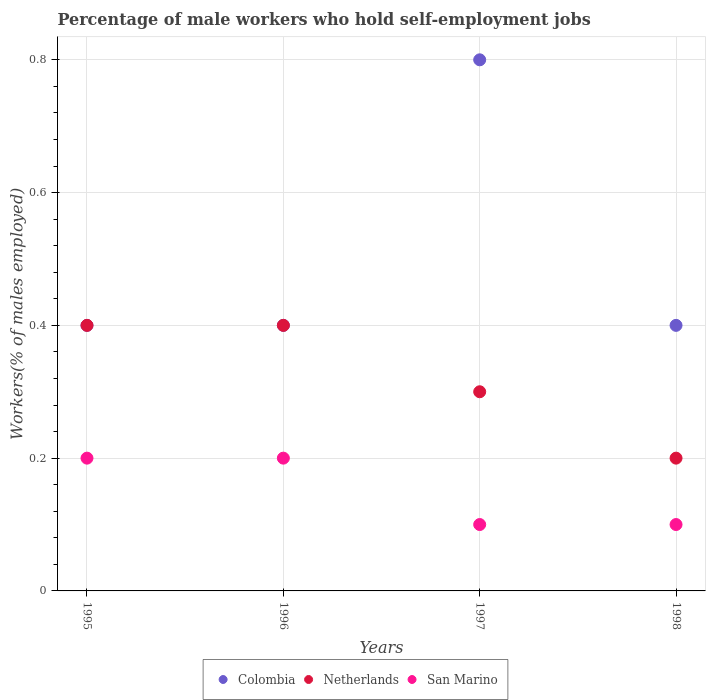How many different coloured dotlines are there?
Your answer should be very brief. 3. What is the percentage of self-employed male workers in San Marino in 1998?
Provide a succinct answer. 0.1. Across all years, what is the maximum percentage of self-employed male workers in San Marino?
Offer a very short reply. 0.2. Across all years, what is the minimum percentage of self-employed male workers in San Marino?
Make the answer very short. 0.1. In which year was the percentage of self-employed male workers in Netherlands maximum?
Ensure brevity in your answer.  1995. What is the total percentage of self-employed male workers in Colombia in the graph?
Offer a terse response. 2. What is the difference between the percentage of self-employed male workers in Netherlands in 1997 and the percentage of self-employed male workers in Colombia in 1996?
Offer a very short reply. -0.1. What is the average percentage of self-employed male workers in Colombia per year?
Ensure brevity in your answer.  0.5. In the year 1995, what is the difference between the percentage of self-employed male workers in San Marino and percentage of self-employed male workers in Netherlands?
Give a very brief answer. -0.2. In how many years, is the percentage of self-employed male workers in Colombia greater than 0.68 %?
Keep it short and to the point. 1. Is the percentage of self-employed male workers in Netherlands in 1997 less than that in 1998?
Offer a terse response. No. Is the difference between the percentage of self-employed male workers in San Marino in 1995 and 1996 greater than the difference between the percentage of self-employed male workers in Netherlands in 1995 and 1996?
Make the answer very short. No. What is the difference between the highest and the second highest percentage of self-employed male workers in Colombia?
Offer a very short reply. 0.4. What is the difference between the highest and the lowest percentage of self-employed male workers in San Marino?
Ensure brevity in your answer.  0.1. In how many years, is the percentage of self-employed male workers in Netherlands greater than the average percentage of self-employed male workers in Netherlands taken over all years?
Your answer should be compact. 2. Is the sum of the percentage of self-employed male workers in San Marino in 1995 and 1998 greater than the maximum percentage of self-employed male workers in Colombia across all years?
Give a very brief answer. No. Is the percentage of self-employed male workers in Netherlands strictly greater than the percentage of self-employed male workers in Colombia over the years?
Offer a terse response. No. Is the percentage of self-employed male workers in Netherlands strictly less than the percentage of self-employed male workers in San Marino over the years?
Make the answer very short. No. How many dotlines are there?
Keep it short and to the point. 3. What is the difference between two consecutive major ticks on the Y-axis?
Ensure brevity in your answer.  0.2. Are the values on the major ticks of Y-axis written in scientific E-notation?
Offer a very short reply. No. Does the graph contain any zero values?
Your answer should be compact. No. Does the graph contain grids?
Offer a very short reply. Yes. Where does the legend appear in the graph?
Your response must be concise. Bottom center. How many legend labels are there?
Your response must be concise. 3. What is the title of the graph?
Offer a terse response. Percentage of male workers who hold self-employment jobs. Does "Low income" appear as one of the legend labels in the graph?
Provide a succinct answer. No. What is the label or title of the X-axis?
Offer a very short reply. Years. What is the label or title of the Y-axis?
Your answer should be compact. Workers(% of males employed). What is the Workers(% of males employed) in Colombia in 1995?
Ensure brevity in your answer.  0.4. What is the Workers(% of males employed) of Netherlands in 1995?
Ensure brevity in your answer.  0.4. What is the Workers(% of males employed) in San Marino in 1995?
Provide a short and direct response. 0.2. What is the Workers(% of males employed) in Colombia in 1996?
Offer a very short reply. 0.4. What is the Workers(% of males employed) in Netherlands in 1996?
Offer a very short reply. 0.4. What is the Workers(% of males employed) in San Marino in 1996?
Give a very brief answer. 0.2. What is the Workers(% of males employed) of Colombia in 1997?
Your response must be concise. 0.8. What is the Workers(% of males employed) of Netherlands in 1997?
Your response must be concise. 0.3. What is the Workers(% of males employed) in San Marino in 1997?
Keep it short and to the point. 0.1. What is the Workers(% of males employed) in Colombia in 1998?
Your answer should be compact. 0.4. What is the Workers(% of males employed) in Netherlands in 1998?
Offer a terse response. 0.2. What is the Workers(% of males employed) of San Marino in 1998?
Your answer should be very brief. 0.1. Across all years, what is the maximum Workers(% of males employed) of Colombia?
Your answer should be compact. 0.8. Across all years, what is the maximum Workers(% of males employed) of Netherlands?
Offer a very short reply. 0.4. Across all years, what is the maximum Workers(% of males employed) in San Marino?
Your response must be concise. 0.2. Across all years, what is the minimum Workers(% of males employed) of Colombia?
Ensure brevity in your answer.  0.4. Across all years, what is the minimum Workers(% of males employed) of Netherlands?
Provide a short and direct response. 0.2. Across all years, what is the minimum Workers(% of males employed) of San Marino?
Your answer should be very brief. 0.1. What is the total Workers(% of males employed) in San Marino in the graph?
Provide a succinct answer. 0.6. What is the difference between the Workers(% of males employed) of Colombia in 1995 and that in 1996?
Your answer should be very brief. 0. What is the difference between the Workers(% of males employed) of Colombia in 1995 and that in 1998?
Keep it short and to the point. 0. What is the difference between the Workers(% of males employed) in Netherlands in 1996 and that in 1997?
Keep it short and to the point. 0.1. What is the difference between the Workers(% of males employed) of Colombia in 1996 and that in 1998?
Offer a terse response. 0. What is the difference between the Workers(% of males employed) in Netherlands in 1996 and that in 1998?
Provide a succinct answer. 0.2. What is the difference between the Workers(% of males employed) in Netherlands in 1997 and that in 1998?
Make the answer very short. 0.1. What is the difference between the Workers(% of males employed) in San Marino in 1997 and that in 1998?
Your answer should be very brief. 0. What is the difference between the Workers(% of males employed) of Colombia in 1995 and the Workers(% of males employed) of San Marino in 1996?
Your answer should be very brief. 0.2. What is the difference between the Workers(% of males employed) in Colombia in 1995 and the Workers(% of males employed) in San Marino in 1997?
Ensure brevity in your answer.  0.3. What is the difference between the Workers(% of males employed) of Netherlands in 1995 and the Workers(% of males employed) of San Marino in 1997?
Your answer should be compact. 0.3. What is the difference between the Workers(% of males employed) of Colombia in 1995 and the Workers(% of males employed) of Netherlands in 1998?
Provide a short and direct response. 0.2. What is the difference between the Workers(% of males employed) in Colombia in 1995 and the Workers(% of males employed) in San Marino in 1998?
Offer a terse response. 0.3. What is the difference between the Workers(% of males employed) in Netherlands in 1995 and the Workers(% of males employed) in San Marino in 1998?
Your answer should be compact. 0.3. What is the difference between the Workers(% of males employed) in Colombia in 1996 and the Workers(% of males employed) in San Marino in 1998?
Give a very brief answer. 0.3. What is the difference between the Workers(% of males employed) of Netherlands in 1996 and the Workers(% of males employed) of San Marino in 1998?
Give a very brief answer. 0.3. What is the difference between the Workers(% of males employed) in Colombia in 1997 and the Workers(% of males employed) in Netherlands in 1998?
Keep it short and to the point. 0.6. What is the average Workers(% of males employed) in Colombia per year?
Ensure brevity in your answer.  0.5. What is the average Workers(% of males employed) of Netherlands per year?
Provide a succinct answer. 0.33. What is the average Workers(% of males employed) of San Marino per year?
Your answer should be very brief. 0.15. In the year 1995, what is the difference between the Workers(% of males employed) of Colombia and Workers(% of males employed) of Netherlands?
Your answer should be very brief. 0. In the year 1996, what is the difference between the Workers(% of males employed) of Colombia and Workers(% of males employed) of Netherlands?
Offer a terse response. 0. In the year 1997, what is the difference between the Workers(% of males employed) in Netherlands and Workers(% of males employed) in San Marino?
Give a very brief answer. 0.2. In the year 1998, what is the difference between the Workers(% of males employed) in Colombia and Workers(% of males employed) in San Marino?
Give a very brief answer. 0.3. What is the ratio of the Workers(% of males employed) of Colombia in 1995 to that in 1996?
Your answer should be very brief. 1. What is the ratio of the Workers(% of males employed) of San Marino in 1995 to that in 1997?
Your response must be concise. 2. What is the ratio of the Workers(% of males employed) of Netherlands in 1995 to that in 1998?
Provide a succinct answer. 2. What is the ratio of the Workers(% of males employed) in San Marino in 1995 to that in 1998?
Keep it short and to the point. 2. What is the ratio of the Workers(% of males employed) of Netherlands in 1996 to that in 1997?
Offer a very short reply. 1.33. What is the ratio of the Workers(% of males employed) in San Marino in 1996 to that in 1997?
Offer a very short reply. 2. What is the ratio of the Workers(% of males employed) in Netherlands in 1996 to that in 1998?
Keep it short and to the point. 2. What is the ratio of the Workers(% of males employed) of San Marino in 1997 to that in 1998?
Offer a terse response. 1. What is the difference between the highest and the second highest Workers(% of males employed) of Netherlands?
Your answer should be very brief. 0. What is the difference between the highest and the second highest Workers(% of males employed) of San Marino?
Keep it short and to the point. 0. What is the difference between the highest and the lowest Workers(% of males employed) in Colombia?
Provide a short and direct response. 0.4. What is the difference between the highest and the lowest Workers(% of males employed) of Netherlands?
Keep it short and to the point. 0.2. 